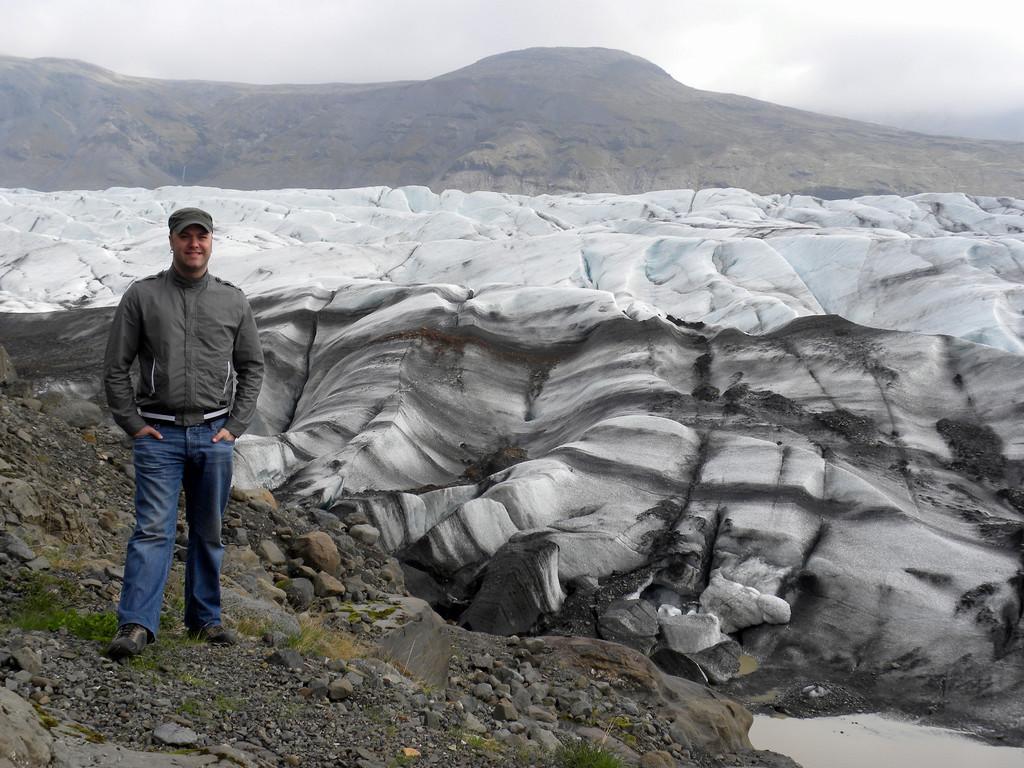How would you summarize this image in a sentence or two? In this image there is one person standing, and at the bottom there is some water and some stones and grass. And in the background there are mountains, and at the top there is sky. 